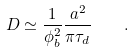Convert formula to latex. <formula><loc_0><loc_0><loc_500><loc_500>D \simeq \frac { 1 } { \phi _ { b } ^ { 2 } } \frac { a ^ { 2 } } { \pi \tau _ { d } } \quad .</formula> 